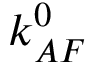Convert formula to latex. <formula><loc_0><loc_0><loc_500><loc_500>k _ { A F } ^ { 0 }</formula> 